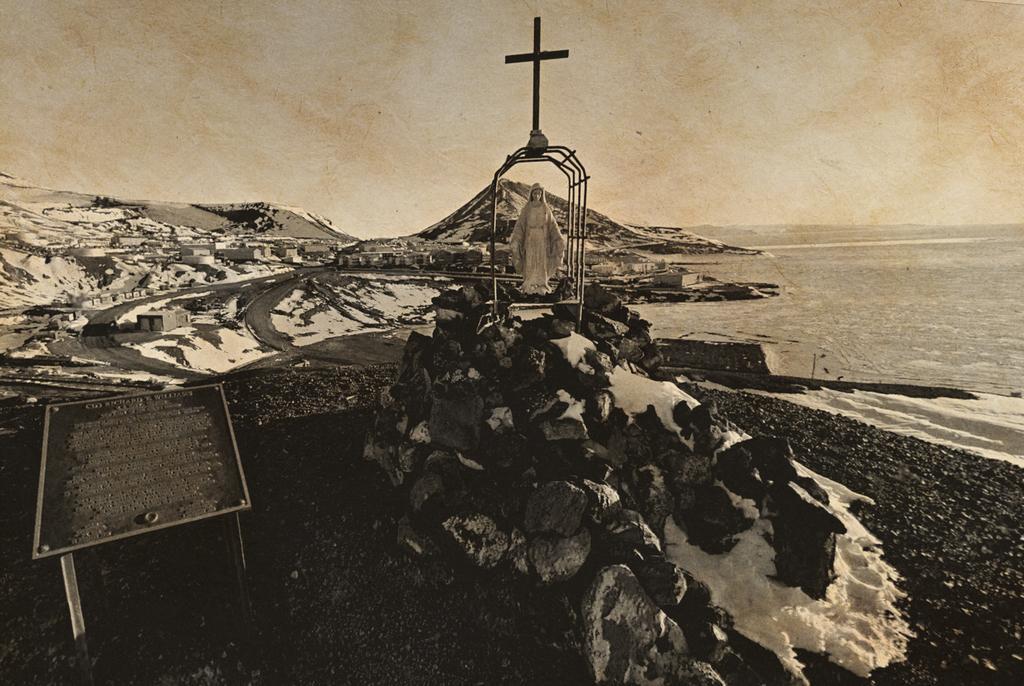In one or two sentences, can you explain what this image depicts? In the picture I can see statue which is in cage and top of it there is holy cross symbol and in the background of the picture there are some houses, water and top of the picture there is clear sky. 